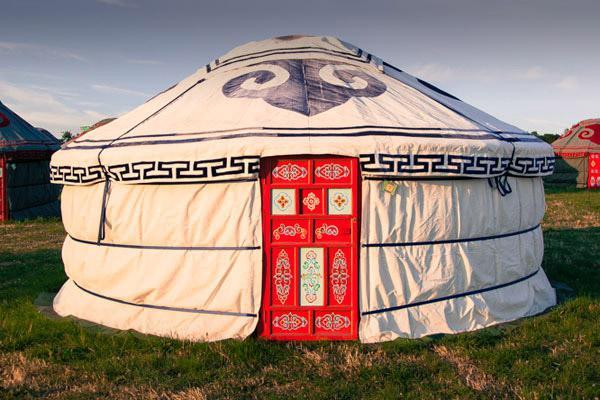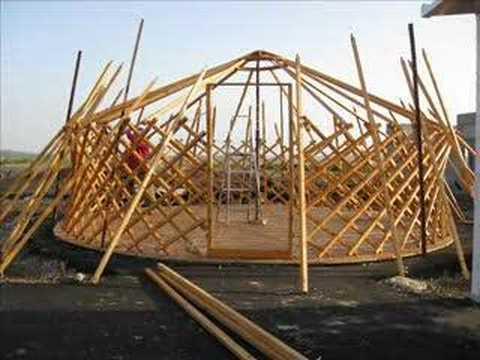The first image is the image on the left, the second image is the image on the right. For the images shown, is this caption "At least one hut is not yet wrapped in fabric." true? Answer yes or no. Yes. The first image is the image on the left, the second image is the image on the right. Evaluate the accuracy of this statement regarding the images: "homes are in the construction phase". Is it true? Answer yes or no. Yes. 